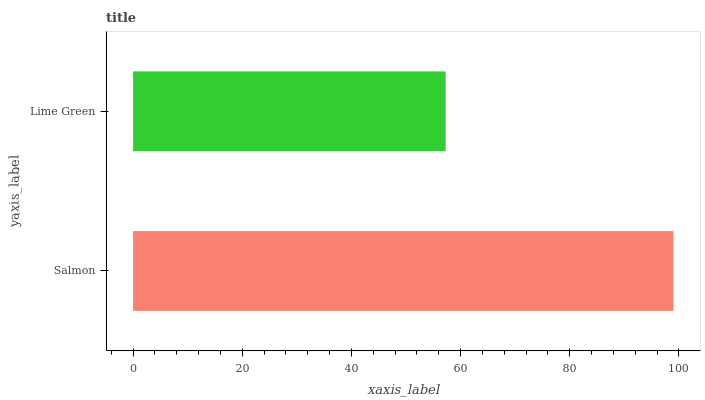Is Lime Green the minimum?
Answer yes or no. Yes. Is Salmon the maximum?
Answer yes or no. Yes. Is Lime Green the maximum?
Answer yes or no. No. Is Salmon greater than Lime Green?
Answer yes or no. Yes. Is Lime Green less than Salmon?
Answer yes or no. Yes. Is Lime Green greater than Salmon?
Answer yes or no. No. Is Salmon less than Lime Green?
Answer yes or no. No. Is Salmon the high median?
Answer yes or no. Yes. Is Lime Green the low median?
Answer yes or no. Yes. Is Lime Green the high median?
Answer yes or no. No. Is Salmon the low median?
Answer yes or no. No. 